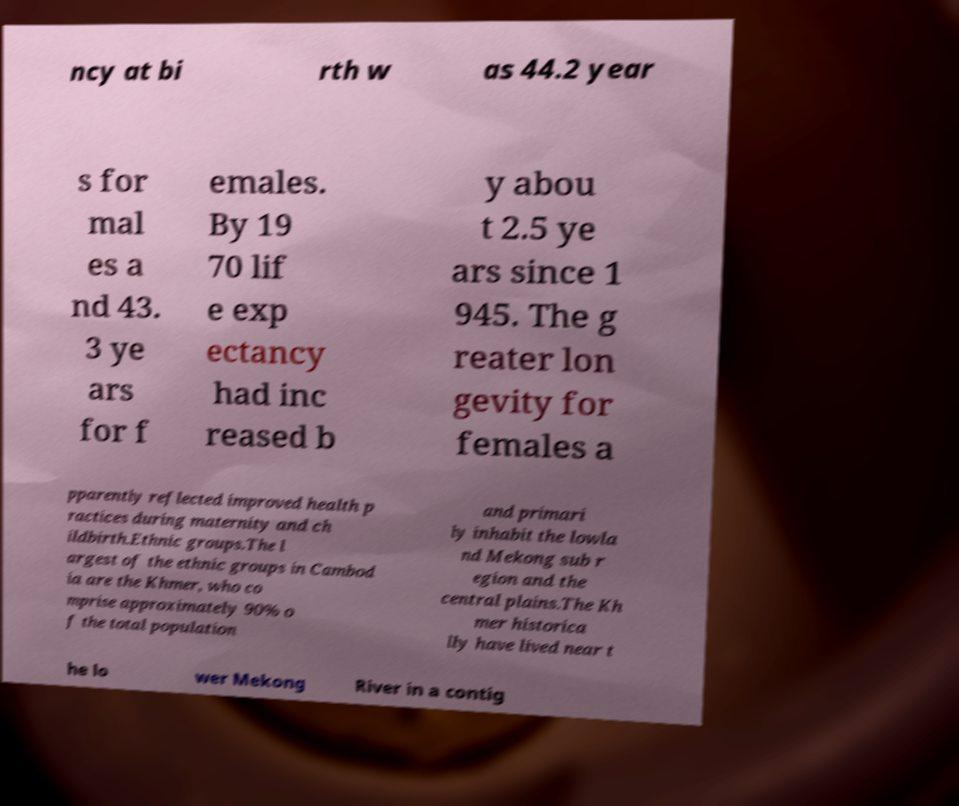Please identify and transcribe the text found in this image. ncy at bi rth w as 44.2 year s for mal es a nd 43. 3 ye ars for f emales. By 19 70 lif e exp ectancy had inc reased b y abou t 2.5 ye ars since 1 945. The g reater lon gevity for females a pparently reflected improved health p ractices during maternity and ch ildbirth.Ethnic groups.The l argest of the ethnic groups in Cambod ia are the Khmer, who co mprise approximately 90% o f the total population and primari ly inhabit the lowla nd Mekong sub r egion and the central plains.The Kh mer historica lly have lived near t he lo wer Mekong River in a contig 